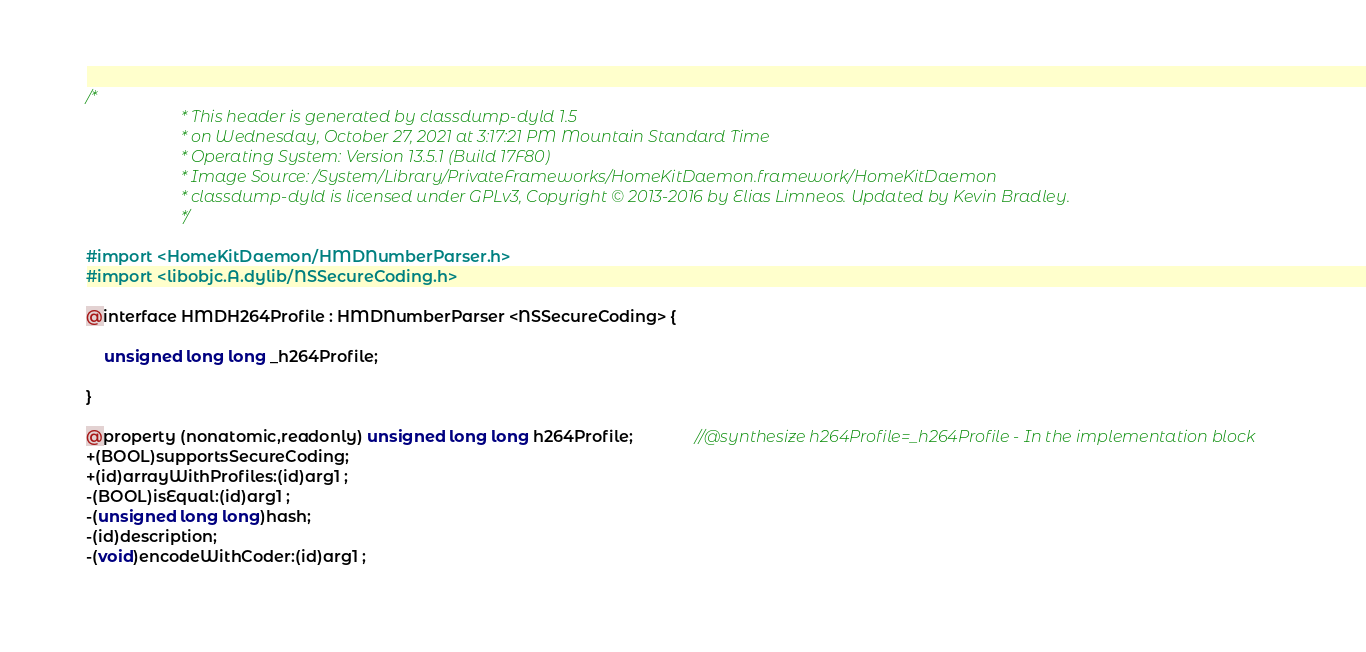Convert code to text. <code><loc_0><loc_0><loc_500><loc_500><_C_>/*
                       * This header is generated by classdump-dyld 1.5
                       * on Wednesday, October 27, 2021 at 3:17:21 PM Mountain Standard Time
                       * Operating System: Version 13.5.1 (Build 17F80)
                       * Image Source: /System/Library/PrivateFrameworks/HomeKitDaemon.framework/HomeKitDaemon
                       * classdump-dyld is licensed under GPLv3, Copyright © 2013-2016 by Elias Limneos. Updated by Kevin Bradley.
                       */

#import <HomeKitDaemon/HMDNumberParser.h>
#import <libobjc.A.dylib/NSSecureCoding.h>

@interface HMDH264Profile : HMDNumberParser <NSSecureCoding> {

	unsigned long long _h264Profile;

}

@property (nonatomic,readonly) unsigned long long h264Profile;              //@synthesize h264Profile=_h264Profile - In the implementation block
+(BOOL)supportsSecureCoding;
+(id)arrayWithProfiles:(id)arg1 ;
-(BOOL)isEqual:(id)arg1 ;
-(unsigned long long)hash;
-(id)description;
-(void)encodeWithCoder:(id)arg1 ;</code> 